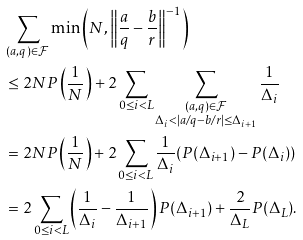<formula> <loc_0><loc_0><loc_500><loc_500>& \sum _ { ( a , q ) \in \mathcal { F } } \min \left ( N , \left \| \frac { a } { q } - \frac { b } { r } \right \| ^ { - 1 } \right ) \\ & \leq 2 N P \left ( \frac { 1 } { N } \right ) + 2 \sum _ { 0 \leq i < L } \sum _ { \substack { ( a , q ) \in \mathcal { F } \\ \Delta _ { i } < | a / q - b / r | \leq \Delta _ { i + 1 } } } \frac { 1 } { \Delta _ { i } } \\ & = 2 N P \left ( \frac { 1 } { N } \right ) + 2 \sum _ { 0 \leq i < L } \frac { 1 } { \Delta _ { i } } ( P ( \Delta _ { i + 1 } ) - P ( \Delta _ { i } ) ) \\ & = 2 \sum _ { 0 \leq i < L } \left ( \frac { 1 } { \Delta _ { i } } - \frac { 1 } { \Delta _ { i + 1 } } \right ) P ( \Delta _ { i + 1 } ) + \frac { 2 } { \Delta _ { L } } P ( \Delta _ { L } ) .</formula> 